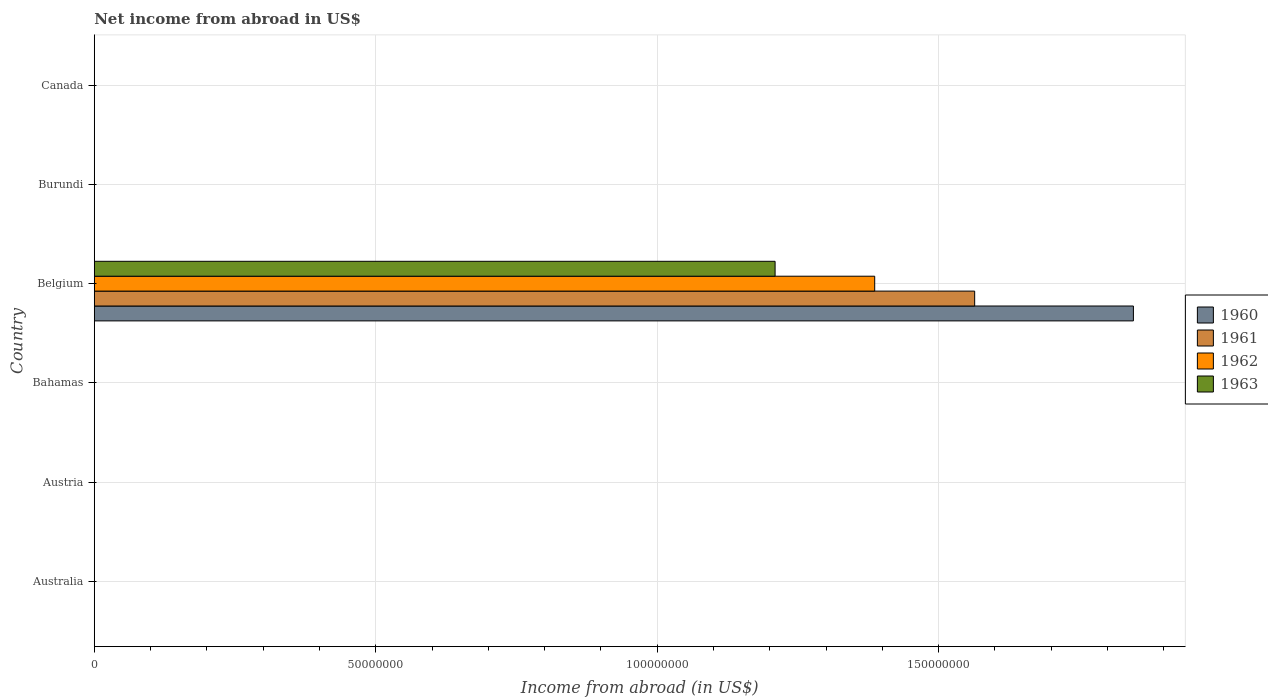How many different coloured bars are there?
Provide a succinct answer. 4. Across all countries, what is the maximum net income from abroad in 1962?
Give a very brief answer. 1.39e+08. In which country was the net income from abroad in 1963 maximum?
Provide a succinct answer. Belgium. What is the total net income from abroad in 1963 in the graph?
Offer a terse response. 1.21e+08. What is the average net income from abroad in 1960 per country?
Keep it short and to the point. 3.08e+07. What is the difference between the net income from abroad in 1963 and net income from abroad in 1960 in Belgium?
Give a very brief answer. -6.37e+07. In how many countries, is the net income from abroad in 1960 greater than 120000000 US$?
Offer a very short reply. 1. What is the difference between the highest and the lowest net income from abroad in 1962?
Offer a terse response. 1.39e+08. Is it the case that in every country, the sum of the net income from abroad in 1960 and net income from abroad in 1961 is greater than the sum of net income from abroad in 1963 and net income from abroad in 1962?
Offer a terse response. No. How many bars are there?
Your response must be concise. 4. What is the difference between two consecutive major ticks on the X-axis?
Your response must be concise. 5.00e+07. Does the graph contain any zero values?
Your answer should be very brief. Yes. Where does the legend appear in the graph?
Provide a succinct answer. Center right. How are the legend labels stacked?
Make the answer very short. Vertical. What is the title of the graph?
Offer a very short reply. Net income from abroad in US$. What is the label or title of the X-axis?
Make the answer very short. Income from abroad (in US$). What is the Income from abroad (in US$) of 1961 in Australia?
Give a very brief answer. 0. What is the Income from abroad (in US$) in 1960 in Austria?
Provide a succinct answer. 0. What is the Income from abroad (in US$) in 1961 in Austria?
Offer a terse response. 0. What is the Income from abroad (in US$) in 1960 in Bahamas?
Give a very brief answer. 0. What is the Income from abroad (in US$) in 1962 in Bahamas?
Provide a short and direct response. 0. What is the Income from abroad (in US$) of 1963 in Bahamas?
Ensure brevity in your answer.  0. What is the Income from abroad (in US$) in 1960 in Belgium?
Your response must be concise. 1.85e+08. What is the Income from abroad (in US$) of 1961 in Belgium?
Your answer should be compact. 1.56e+08. What is the Income from abroad (in US$) of 1962 in Belgium?
Give a very brief answer. 1.39e+08. What is the Income from abroad (in US$) of 1963 in Belgium?
Make the answer very short. 1.21e+08. What is the Income from abroad (in US$) of 1960 in Burundi?
Keep it short and to the point. 0. What is the Income from abroad (in US$) in 1962 in Burundi?
Make the answer very short. 0. What is the Income from abroad (in US$) in 1963 in Burundi?
Offer a terse response. 0. What is the Income from abroad (in US$) in 1960 in Canada?
Your answer should be very brief. 0. What is the Income from abroad (in US$) of 1961 in Canada?
Provide a succinct answer. 0. What is the Income from abroad (in US$) of 1963 in Canada?
Your response must be concise. 0. Across all countries, what is the maximum Income from abroad (in US$) of 1960?
Your answer should be compact. 1.85e+08. Across all countries, what is the maximum Income from abroad (in US$) in 1961?
Your answer should be very brief. 1.56e+08. Across all countries, what is the maximum Income from abroad (in US$) of 1962?
Your response must be concise. 1.39e+08. Across all countries, what is the maximum Income from abroad (in US$) of 1963?
Your answer should be compact. 1.21e+08. Across all countries, what is the minimum Income from abroad (in US$) in 1961?
Your response must be concise. 0. What is the total Income from abroad (in US$) in 1960 in the graph?
Ensure brevity in your answer.  1.85e+08. What is the total Income from abroad (in US$) in 1961 in the graph?
Offer a terse response. 1.56e+08. What is the total Income from abroad (in US$) in 1962 in the graph?
Offer a very short reply. 1.39e+08. What is the total Income from abroad (in US$) in 1963 in the graph?
Offer a terse response. 1.21e+08. What is the average Income from abroad (in US$) of 1960 per country?
Your answer should be compact. 3.08e+07. What is the average Income from abroad (in US$) of 1961 per country?
Your response must be concise. 2.61e+07. What is the average Income from abroad (in US$) in 1962 per country?
Provide a short and direct response. 2.31e+07. What is the average Income from abroad (in US$) in 1963 per country?
Your response must be concise. 2.02e+07. What is the difference between the Income from abroad (in US$) in 1960 and Income from abroad (in US$) in 1961 in Belgium?
Provide a short and direct response. 2.82e+07. What is the difference between the Income from abroad (in US$) in 1960 and Income from abroad (in US$) in 1962 in Belgium?
Give a very brief answer. 4.60e+07. What is the difference between the Income from abroad (in US$) in 1960 and Income from abroad (in US$) in 1963 in Belgium?
Your answer should be compact. 6.37e+07. What is the difference between the Income from abroad (in US$) of 1961 and Income from abroad (in US$) of 1962 in Belgium?
Give a very brief answer. 1.78e+07. What is the difference between the Income from abroad (in US$) in 1961 and Income from abroad (in US$) in 1963 in Belgium?
Offer a very short reply. 3.55e+07. What is the difference between the Income from abroad (in US$) of 1962 and Income from abroad (in US$) of 1963 in Belgium?
Your response must be concise. 1.77e+07. What is the difference between the highest and the lowest Income from abroad (in US$) of 1960?
Make the answer very short. 1.85e+08. What is the difference between the highest and the lowest Income from abroad (in US$) in 1961?
Provide a short and direct response. 1.56e+08. What is the difference between the highest and the lowest Income from abroad (in US$) of 1962?
Give a very brief answer. 1.39e+08. What is the difference between the highest and the lowest Income from abroad (in US$) of 1963?
Your answer should be very brief. 1.21e+08. 